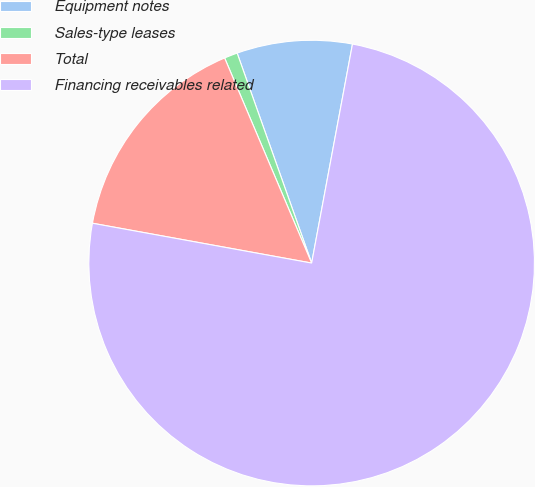Convert chart. <chart><loc_0><loc_0><loc_500><loc_500><pie_chart><fcel>Equipment notes<fcel>Sales-type leases<fcel>Total<fcel>Financing receivables related<nl><fcel>8.36%<fcel>0.96%<fcel>15.75%<fcel>74.92%<nl></chart> 